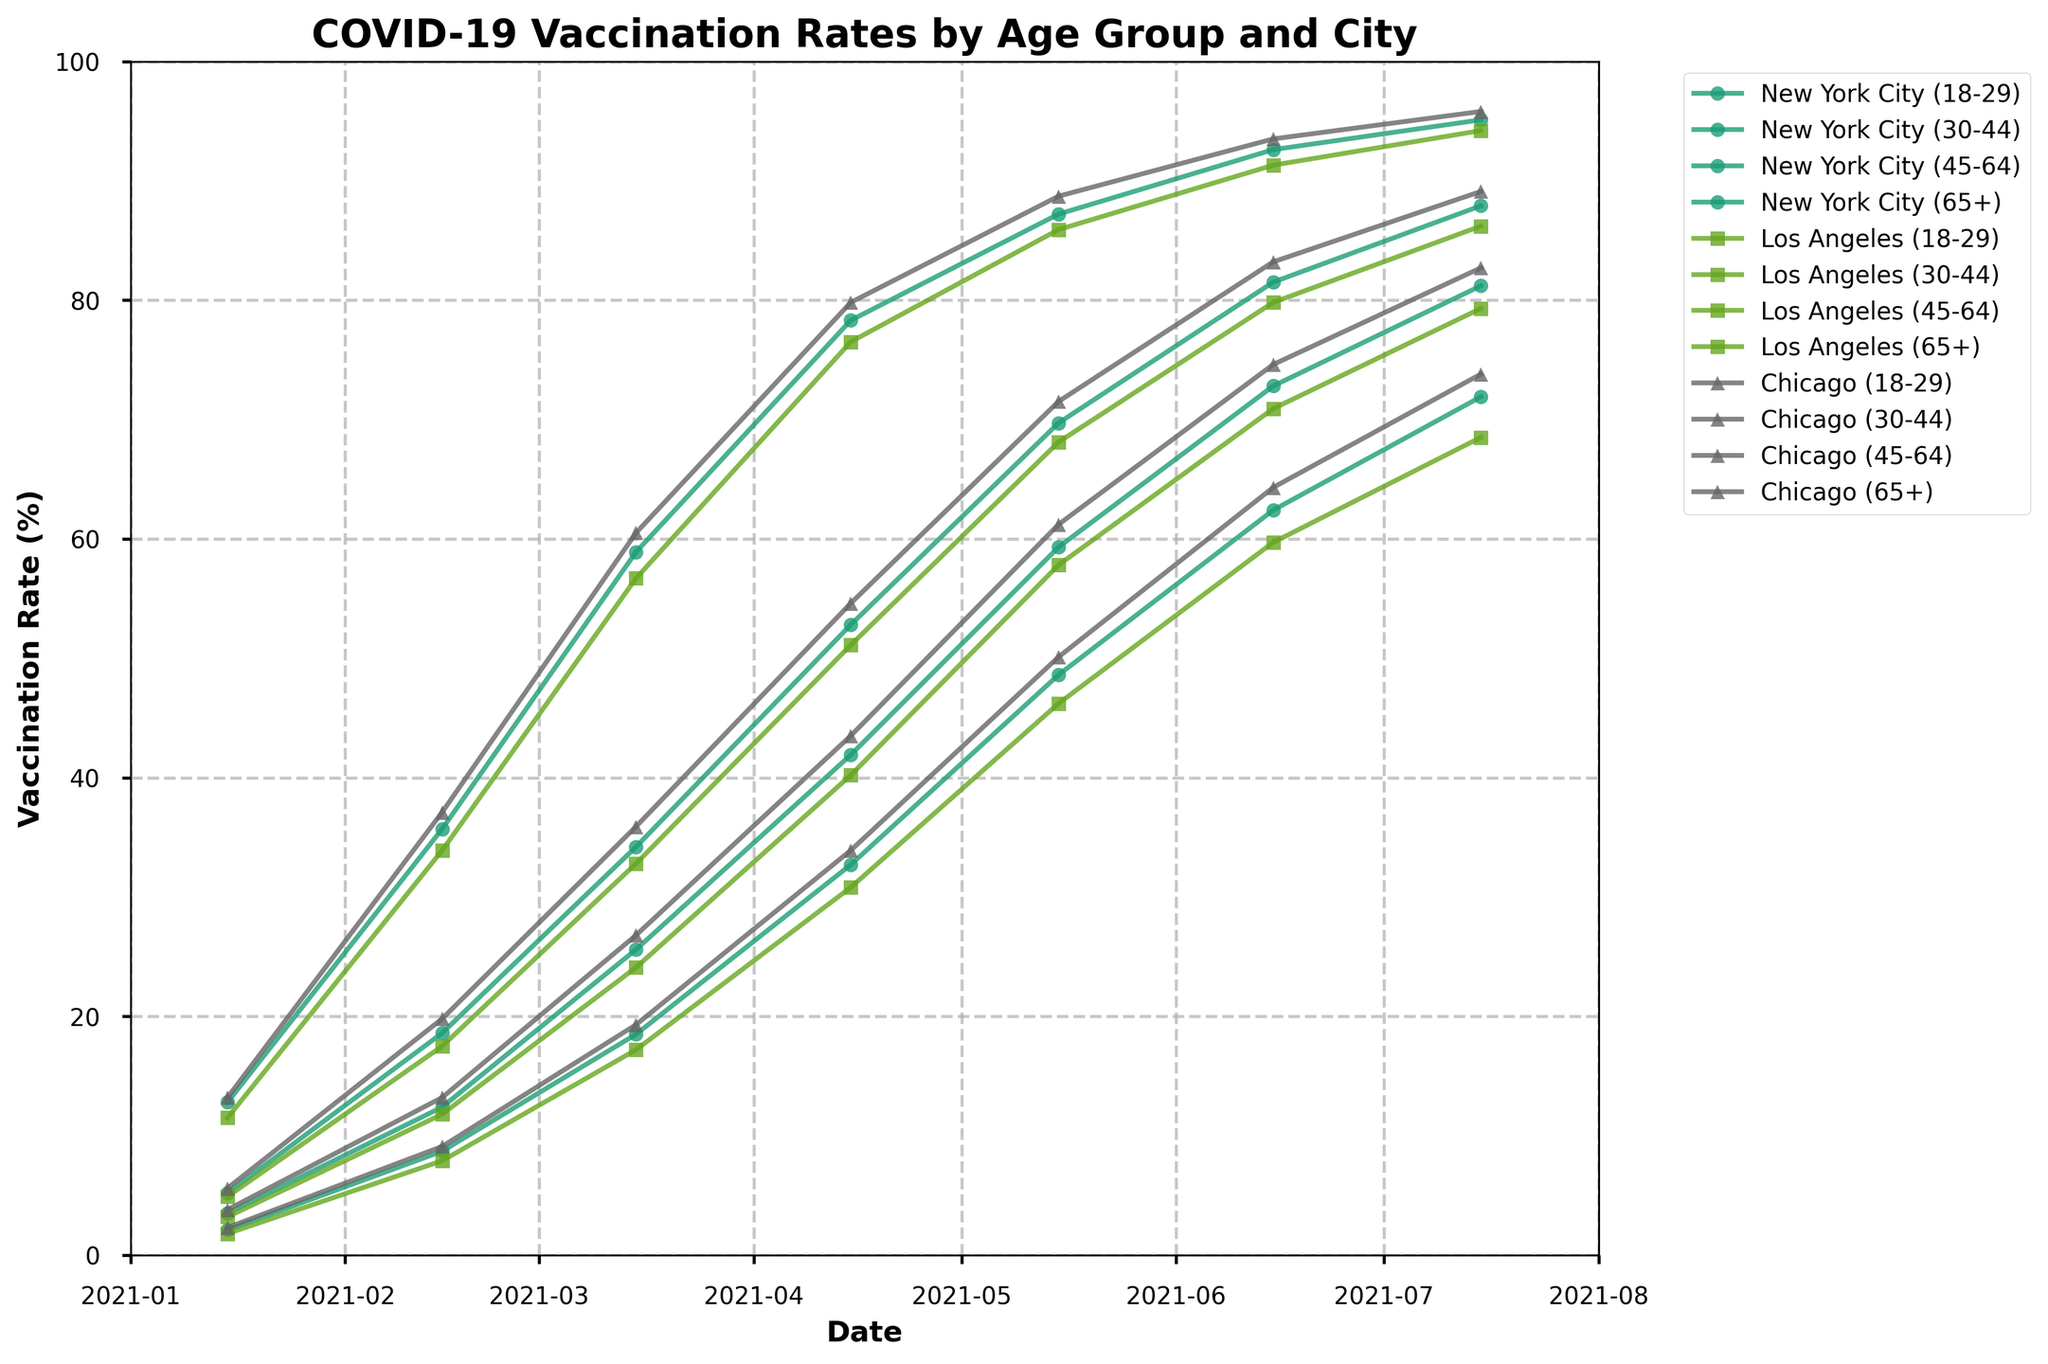What is the vaccination rate of the age group 65+ in New York City on July 15, 2021? Locate the curve for New York City and find the data from July 15, 2021. Check the value at 65+.
Answer: 95.1 Which city had the highest vaccination rate for the age group 18-29 on February 15, 2021? Compare the 18-29 vaccination rates on February 15, 2021 across New York City, Los Angeles, and Chicago.
Answer: Chicago How did the vaccination rate for the age group 30-44 change in Los Angeles between May 15, 2021, and June 15, 2021? Find the data points for Los Angeles on May 15, 2021, and June 15, 2021. Calculate the difference between these points for the 30-44 age group.
Answer: 13.1 (72.8 - 59.7) By how much did the vaccination rate for people aged 45-64 in Chicago increase between March 15, 2021, and April 15, 2021? Check the values for Chicago on March 15, 2021, and April 15, 2021 for the 45-64 age group, and compute the difference.
Answer: 18.7 (54.6 - 35.9) What is the average vaccination rate for the age group 18-29 across all three cities on January 15, 2021? Take the vaccination rates for the age group 18-29 on January 15, 2021, across New York City, Los Angeles, and Chicago, sum them up and divide by 3.
Answer: 2.07 ((2.1 + 1.8 + 2.3)/3) Which age group had the smallest increase in vaccination rate in Chicago from June 15, 2021, to July 15, 2021? Compare the differences in vaccination rates between June 15, 2021, and July 15, 2021, for each age group in Chicago.
Answer: 65+ (2.3) What visual indicator helps to distinguish between the vaccination rates for different cities? Observe the colors and markers used for each city's plots in the chart to identify how they are distinguished.
Answer: Colors and markers Does the vaccination trend for people aged 65+ in New York City show a steady increase over time? Follow the 65+ age group's curve in New York City from January 15, 2021, to July 15, 2021, to see the pattern.
Answer: Yes What is the largest gap in vaccination rates between any two age groups in New York City on April 15, 2021? Identify vaccination rates for all age groups in New York City on April 15, 2021, calculate the differences between them, and find the largest difference.
Answer: 45.6 (78.3 - 32.7) By what percentage did the vaccination rate for the age group 30-44 in Chicago grow from January 15, 2021, to July 15, 2021? Obtain the vaccination rates for age group 30-44 in Chicago on January 15, 2021, and July 15, 2021, calculate the percentage increase: ((July rate - January rate) / January rate) * 100.
Answer: 2076.32% (((82.7 - 3.8) / 3.8) * 100) 